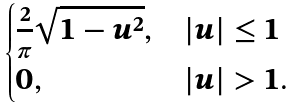<formula> <loc_0><loc_0><loc_500><loc_500>\begin{cases} \frac { 2 } { \pi } \sqrt { 1 - u ^ { 2 } } , & | u | \leq 1 \\ 0 , & | u | > 1 . \end{cases}</formula> 